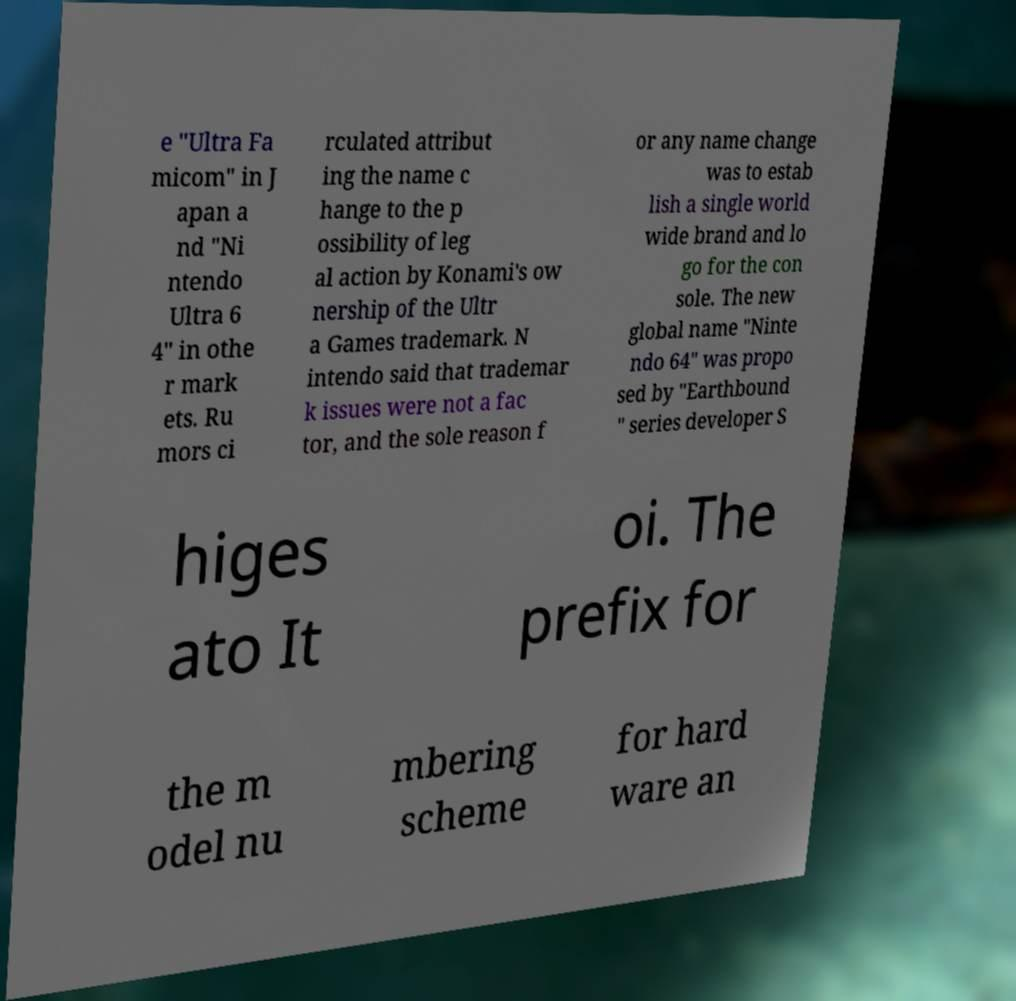Could you assist in decoding the text presented in this image and type it out clearly? e "Ultra Fa micom" in J apan a nd "Ni ntendo Ultra 6 4" in othe r mark ets. Ru mors ci rculated attribut ing the name c hange to the p ossibility of leg al action by Konami's ow nership of the Ultr a Games trademark. N intendo said that trademar k issues were not a fac tor, and the sole reason f or any name change was to estab lish a single world wide brand and lo go for the con sole. The new global name "Ninte ndo 64" was propo sed by "Earthbound " series developer S higes ato It oi. The prefix for the m odel nu mbering scheme for hard ware an 